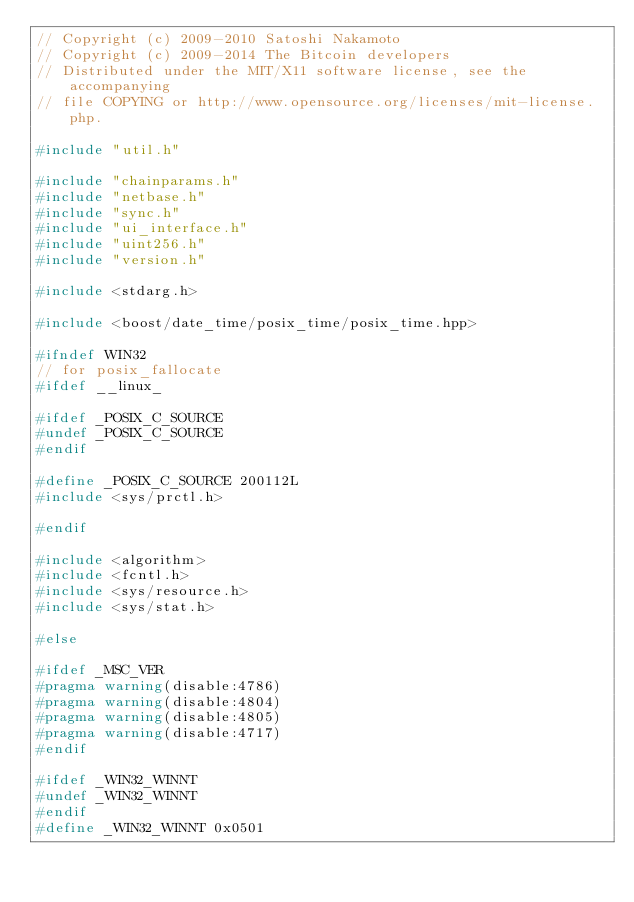<code> <loc_0><loc_0><loc_500><loc_500><_C++_>// Copyright (c) 2009-2010 Satoshi Nakamoto
// Copyright (c) 2009-2014 The Bitcoin developers
// Distributed under the MIT/X11 software license, see the accompanying
// file COPYING or http://www.opensource.org/licenses/mit-license.php.

#include "util.h"

#include "chainparams.h"
#include "netbase.h"
#include "sync.h"
#include "ui_interface.h"
#include "uint256.h"
#include "version.h"

#include <stdarg.h>

#include <boost/date_time/posix_time/posix_time.hpp>

#ifndef WIN32
// for posix_fallocate
#ifdef __linux_

#ifdef _POSIX_C_SOURCE
#undef _POSIX_C_SOURCE
#endif

#define _POSIX_C_SOURCE 200112L
#include <sys/prctl.h>

#endif

#include <algorithm>
#include <fcntl.h>
#include <sys/resource.h>
#include <sys/stat.h>

#else

#ifdef _MSC_VER
#pragma warning(disable:4786)
#pragma warning(disable:4804)
#pragma warning(disable:4805)
#pragma warning(disable:4717)
#endif

#ifdef _WIN32_WINNT
#undef _WIN32_WINNT
#endif
#define _WIN32_WINNT 0x0501
</code> 